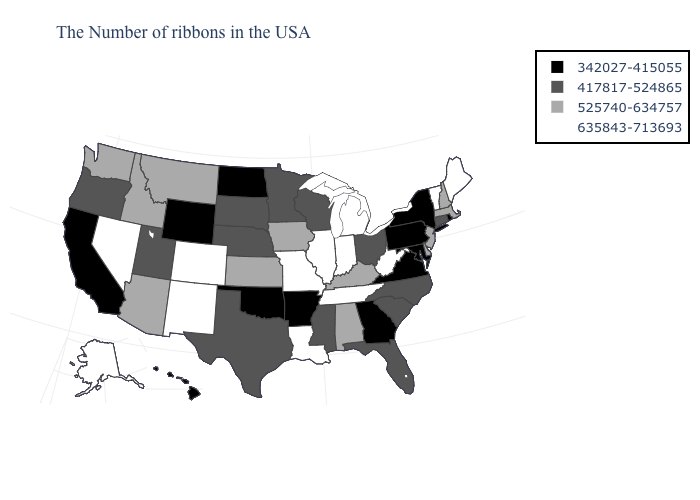Name the states that have a value in the range 342027-415055?
Be succinct. Rhode Island, New York, Maryland, Pennsylvania, Virginia, Georgia, Arkansas, Oklahoma, North Dakota, Wyoming, California, Hawaii. Name the states that have a value in the range 417817-524865?
Short answer required. Connecticut, North Carolina, South Carolina, Ohio, Florida, Wisconsin, Mississippi, Minnesota, Nebraska, Texas, South Dakota, Utah, Oregon. What is the highest value in states that border New Mexico?
Short answer required. 635843-713693. What is the value of Utah?
Quick response, please. 417817-524865. Does Nebraska have the lowest value in the MidWest?
Answer briefly. No. Which states have the highest value in the USA?
Short answer required. Maine, Vermont, West Virginia, Michigan, Indiana, Tennessee, Illinois, Louisiana, Missouri, Colorado, New Mexico, Nevada, Alaska. Which states have the lowest value in the MidWest?
Write a very short answer. North Dakota. What is the value of Tennessee?
Concise answer only. 635843-713693. Does Georgia have the lowest value in the South?
Keep it brief. Yes. Among the states that border Virginia , does Maryland have the lowest value?
Give a very brief answer. Yes. What is the lowest value in the Northeast?
Keep it brief. 342027-415055. Does Massachusetts have the lowest value in the Northeast?
Give a very brief answer. No. Does Vermont have the same value as Colorado?
Give a very brief answer. Yes. Does New Mexico have the highest value in the West?
Keep it brief. Yes. Among the states that border Kentucky , does West Virginia have the lowest value?
Keep it brief. No. 